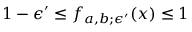<formula> <loc_0><loc_0><loc_500><loc_500>1 - \epsilon ^ { \prime } \leq f _ { a , b ; \epsilon ^ { \prime } } ( x ) \leq 1</formula> 